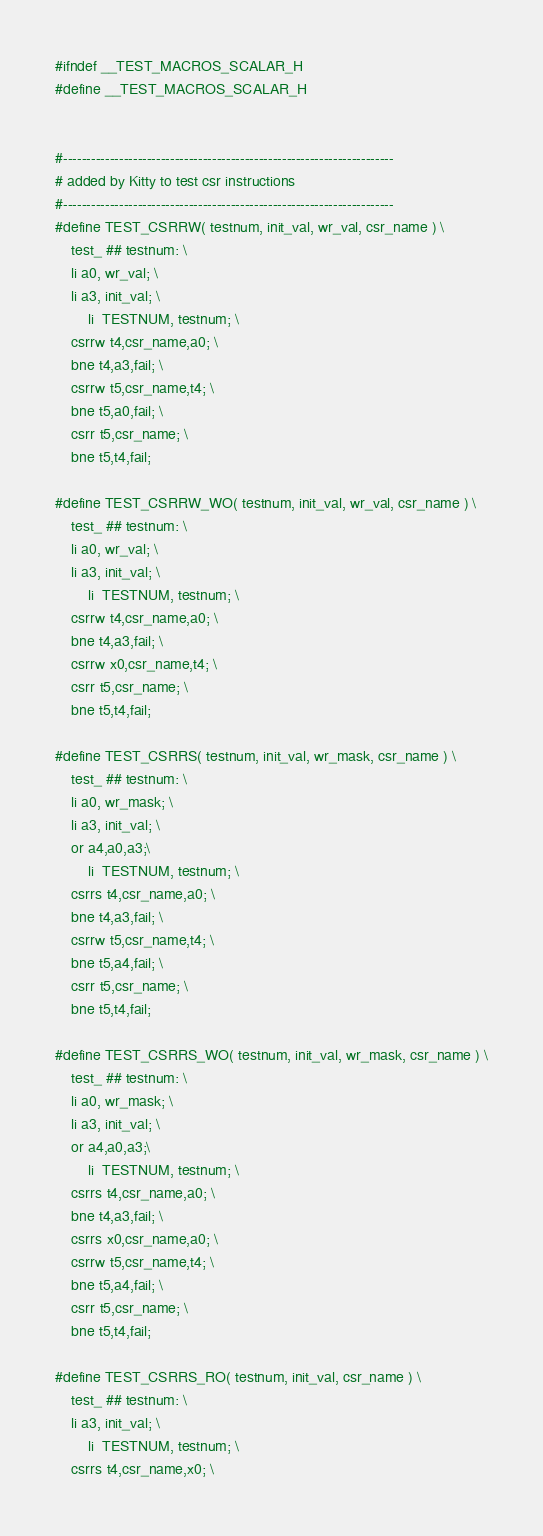Convert code to text. <code><loc_0><loc_0><loc_500><loc_500><_C_>
#ifndef __TEST_MACROS_SCALAR_H
#define __TEST_MACROS_SCALAR_H


#-----------------------------------------------------------------------
# added by Kitty to test csr instructions
#-----------------------------------------------------------------------
#define TEST_CSRRW( testnum, init_val, wr_val, csr_name ) \
	test_ ## testnum: \
	li a0, wr_val; \
	li a3, init_val; \
    	li  TESTNUM, testnum; \
	csrrw t4,csr_name,a0; \
	bne t4,a3,fail; \
	csrrw t5,csr_name,t4; \
	bne t5,a0,fail; \
	csrr t5,csr_name; \
	bne t5,t4,fail;

#define TEST_CSRRW_WO( testnum, init_val, wr_val, csr_name ) \
	test_ ## testnum: \
	li a0, wr_val; \
	li a3, init_val; \
    	li  TESTNUM, testnum; \
	csrrw t4,csr_name,a0; \
	bne t4,a3,fail; \
	csrrw x0,csr_name,t4; \
	csrr t5,csr_name; \
	bne t5,t4,fail;

#define TEST_CSRRS( testnum, init_val, wr_mask, csr_name ) \
	test_ ## testnum: \
	li a0, wr_mask; \
	li a3, init_val; \
	or a4,a0,a3;\
    	li  TESTNUM, testnum; \
	csrrs t4,csr_name,a0; \
	bne t4,a3,fail; \
	csrrw t5,csr_name,t4; \
	bne t5,a4,fail; \
	csrr t5,csr_name; \
	bne t5,t4,fail;

#define TEST_CSRRS_WO( testnum, init_val, wr_mask, csr_name ) \
	test_ ## testnum: \
	li a0, wr_mask; \
	li a3, init_val; \
	or a4,a0,a3;\
    	li  TESTNUM, testnum; \
	csrrs t4,csr_name,a0; \
	bne t4,a3,fail; \
	csrrs x0,csr_name,a0; \
	csrrw t5,csr_name,t4; \
	bne t5,a4,fail; \
	csrr t5,csr_name; \
	bne t5,t4,fail;

#define TEST_CSRRS_RO( testnum, init_val, csr_name ) \
	test_ ## testnum: \
	li a3, init_val; \
    	li  TESTNUM, testnum; \
	csrrs t4,csr_name,x0; \</code> 